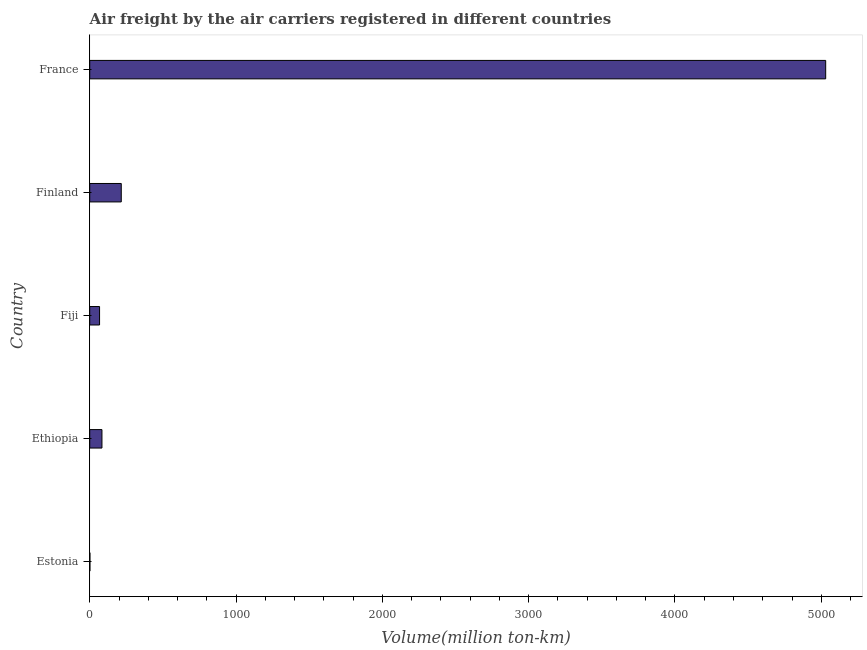Does the graph contain any zero values?
Give a very brief answer. No. What is the title of the graph?
Offer a very short reply. Air freight by the air carriers registered in different countries. What is the label or title of the X-axis?
Your response must be concise. Volume(million ton-km). What is the label or title of the Y-axis?
Provide a short and direct response. Country. What is the air freight in France?
Your response must be concise. 5030.16. Across all countries, what is the maximum air freight?
Ensure brevity in your answer.  5030.16. Across all countries, what is the minimum air freight?
Give a very brief answer. 1.25. In which country was the air freight minimum?
Keep it short and to the point. Estonia. What is the sum of the air freight?
Offer a terse response. 5397.63. What is the difference between the air freight in Estonia and France?
Provide a succinct answer. -5028.91. What is the average air freight per country?
Offer a very short reply. 1079.53. What is the median air freight?
Provide a succinct answer. 83.49. In how many countries, is the air freight greater than 4400 million ton-km?
Keep it short and to the point. 1. What is the difference between the highest and the second highest air freight?
Your answer should be compact. 4814.58. Is the sum of the air freight in Finland and France greater than the maximum air freight across all countries?
Your response must be concise. Yes. What is the difference between the highest and the lowest air freight?
Offer a very short reply. 5028.91. In how many countries, is the air freight greater than the average air freight taken over all countries?
Make the answer very short. 1. How many countries are there in the graph?
Provide a succinct answer. 5. What is the difference between two consecutive major ticks on the X-axis?
Offer a terse response. 1000. Are the values on the major ticks of X-axis written in scientific E-notation?
Ensure brevity in your answer.  No. What is the Volume(million ton-km) of Estonia?
Give a very brief answer. 1.25. What is the Volume(million ton-km) in Ethiopia?
Make the answer very short. 83.49. What is the Volume(million ton-km) of Fiji?
Give a very brief answer. 67.15. What is the Volume(million ton-km) of Finland?
Keep it short and to the point. 215.58. What is the Volume(million ton-km) of France?
Provide a short and direct response. 5030.16. What is the difference between the Volume(million ton-km) in Estonia and Ethiopia?
Make the answer very short. -82.25. What is the difference between the Volume(million ton-km) in Estonia and Fiji?
Give a very brief answer. -65.9. What is the difference between the Volume(million ton-km) in Estonia and Finland?
Offer a very short reply. -214.33. What is the difference between the Volume(million ton-km) in Estonia and France?
Provide a short and direct response. -5028.91. What is the difference between the Volume(million ton-km) in Ethiopia and Fiji?
Offer a terse response. 16.34. What is the difference between the Volume(million ton-km) in Ethiopia and Finland?
Keep it short and to the point. -132.09. What is the difference between the Volume(million ton-km) in Ethiopia and France?
Your response must be concise. -4946.67. What is the difference between the Volume(million ton-km) in Fiji and Finland?
Keep it short and to the point. -148.43. What is the difference between the Volume(million ton-km) in Fiji and France?
Your answer should be very brief. -4963.01. What is the difference between the Volume(million ton-km) in Finland and France?
Offer a terse response. -4814.58. What is the ratio of the Volume(million ton-km) in Estonia to that in Ethiopia?
Offer a very short reply. 0.01. What is the ratio of the Volume(million ton-km) in Estonia to that in Fiji?
Give a very brief answer. 0.02. What is the ratio of the Volume(million ton-km) in Estonia to that in Finland?
Your answer should be very brief. 0.01. What is the ratio of the Volume(million ton-km) in Ethiopia to that in Fiji?
Offer a terse response. 1.24. What is the ratio of the Volume(million ton-km) in Ethiopia to that in Finland?
Give a very brief answer. 0.39. What is the ratio of the Volume(million ton-km) in Ethiopia to that in France?
Make the answer very short. 0.02. What is the ratio of the Volume(million ton-km) in Fiji to that in Finland?
Keep it short and to the point. 0.31. What is the ratio of the Volume(million ton-km) in Fiji to that in France?
Offer a terse response. 0.01. What is the ratio of the Volume(million ton-km) in Finland to that in France?
Your response must be concise. 0.04. 